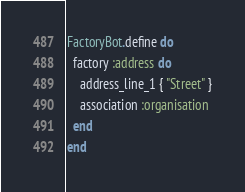<code> <loc_0><loc_0><loc_500><loc_500><_Ruby_>FactoryBot.define do
  factory :address do
    address_line_1 { "Street" }
    association :organisation
  end
end
</code> 